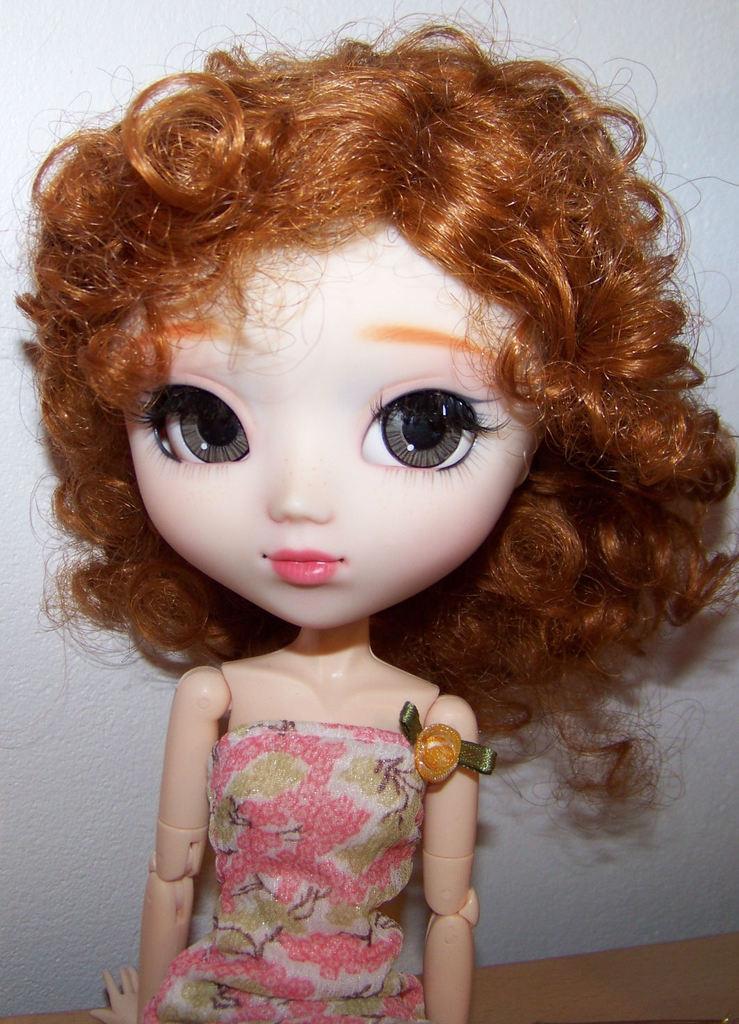Could you give a brief overview of what you see in this image? In this image I can see a toy. In the background there is a wall. 